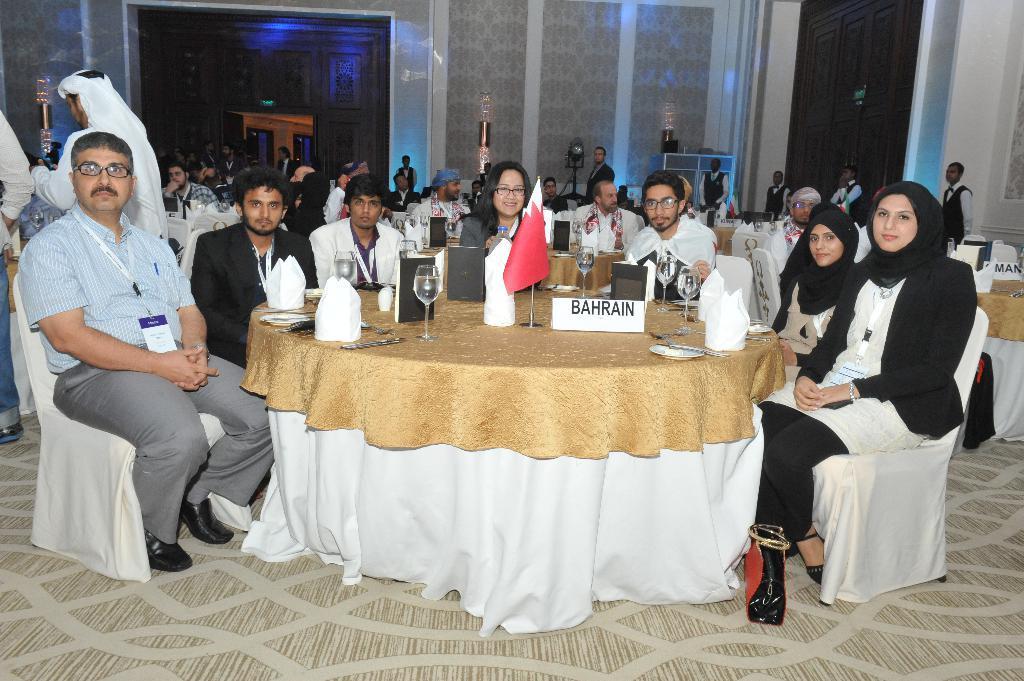Could you give a brief overview of what you see in this image? There is a group of people. Some people are sitting in a chair and some people are standing. There is a table. There is a glass,tissue,plate and name board on a table. We can see in the background walls and pillars. 